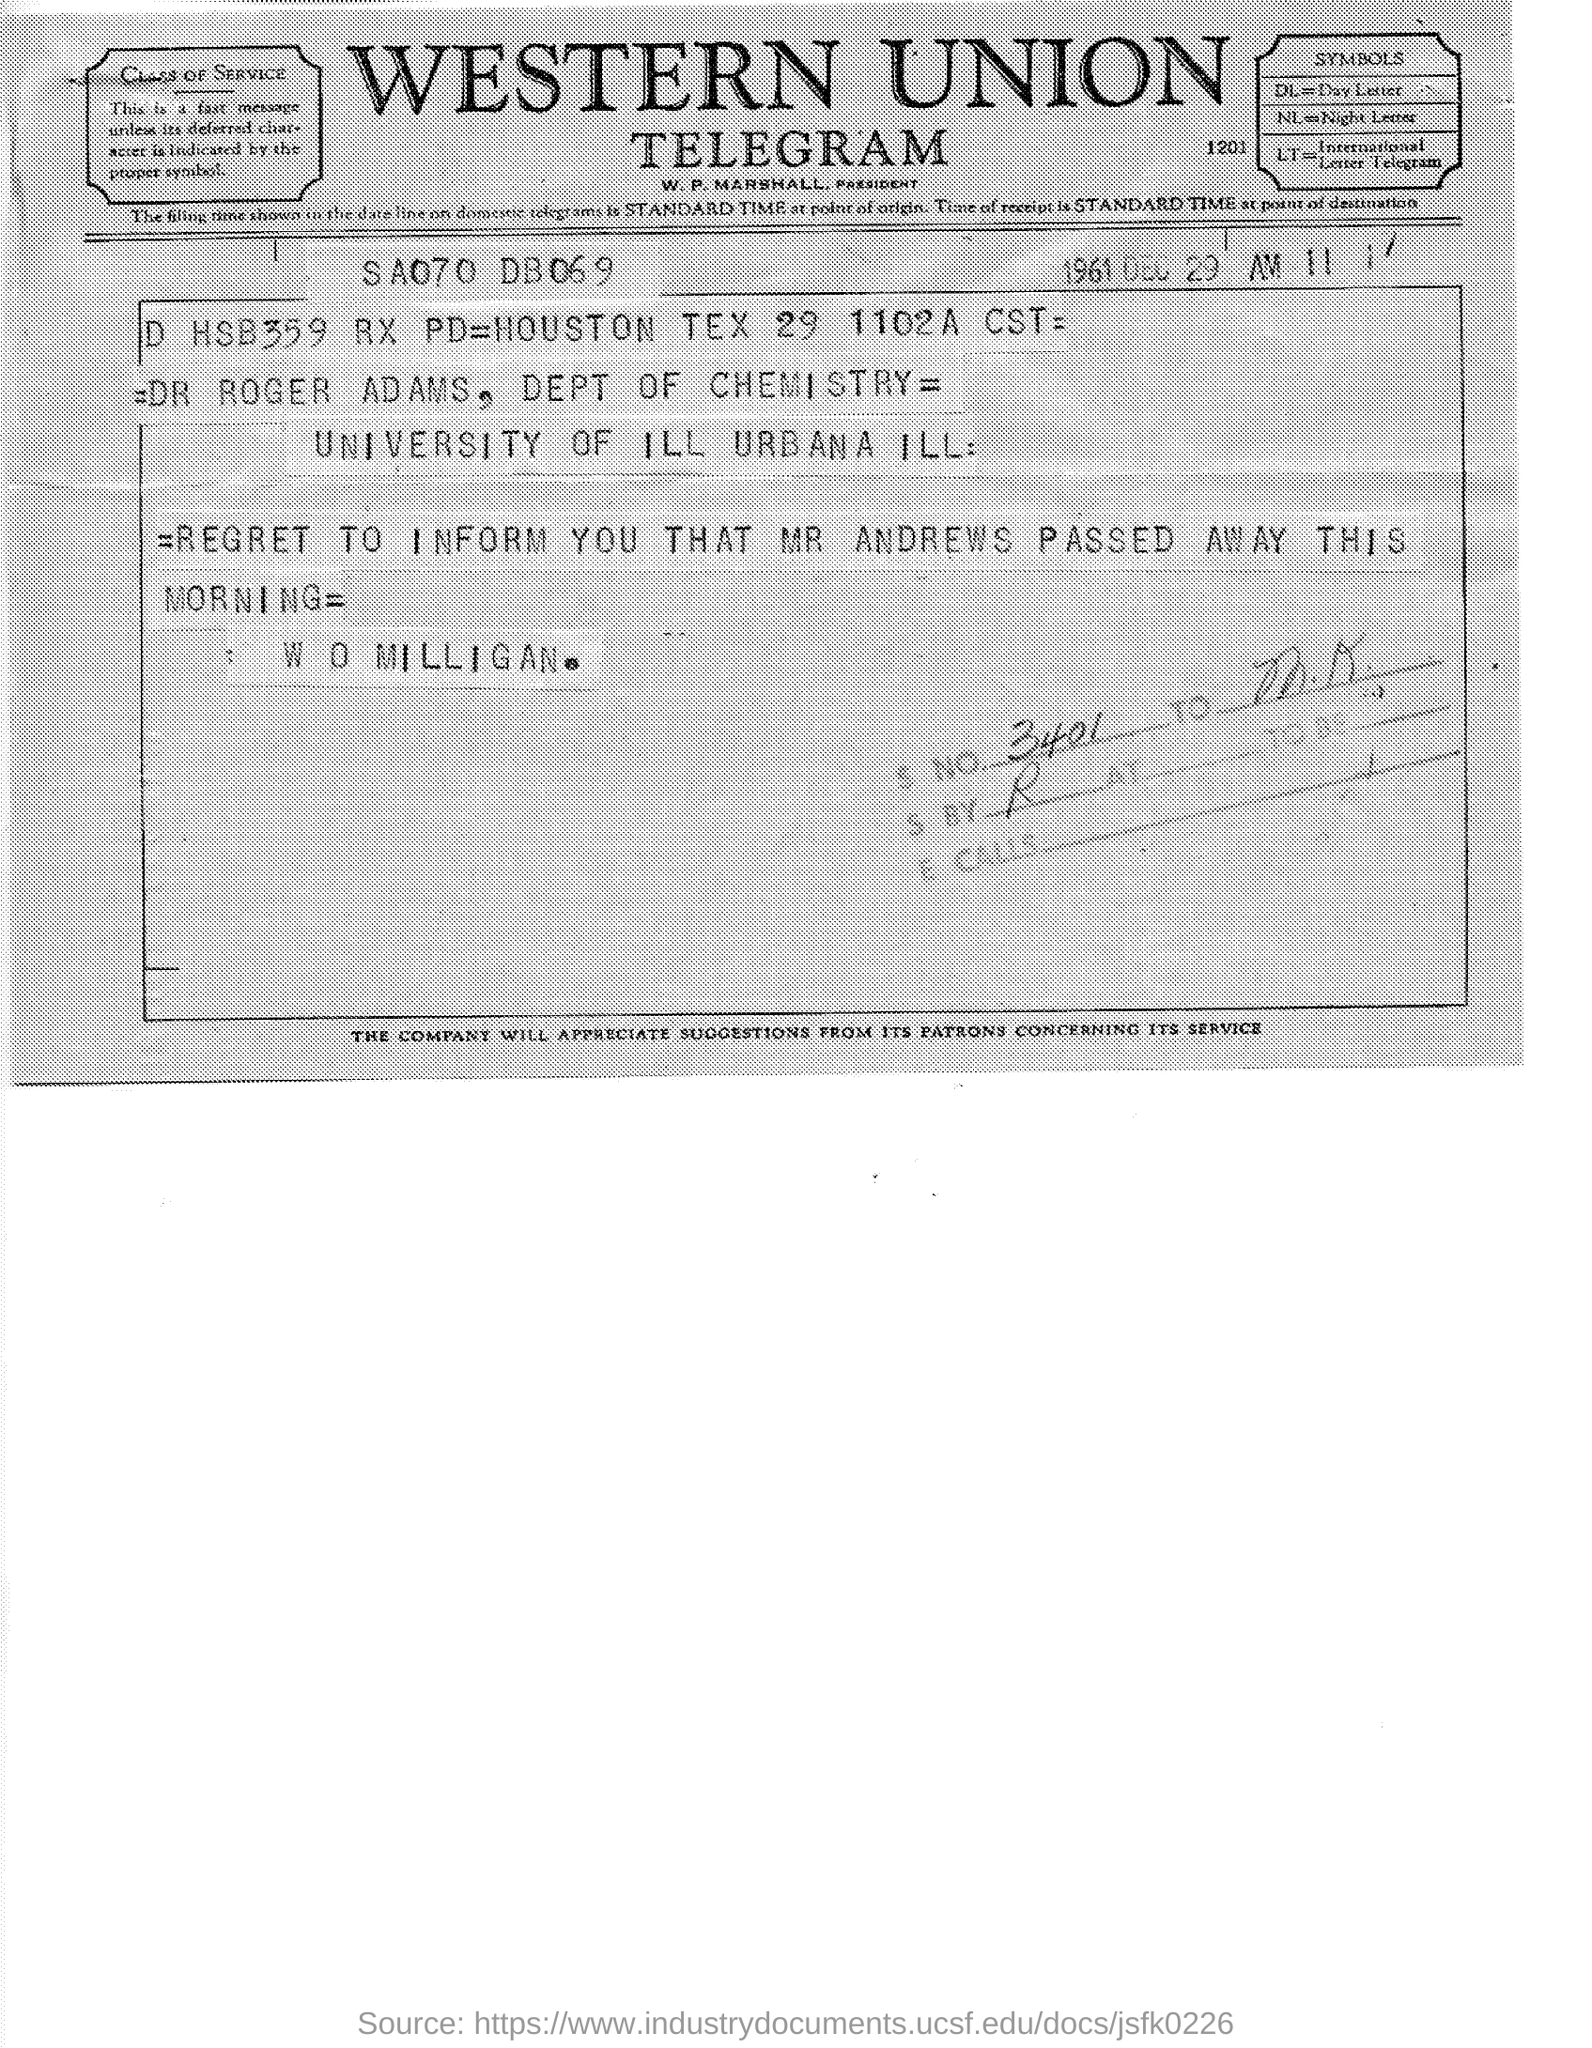What is the date mentioned in the given telegram ?
Offer a very short reply. 1961 DEC 29. What is the name of the union  ?
Ensure brevity in your answer.  Western union. Who is the president of western union ?
Keep it short and to the point. W.P. MARSHALL. What does dl stands for ?
Provide a succinct answer. Day letter. What does nl stands for ?
Provide a short and direct response. Night Letter. Who has passed away this morning as mentioned in the telegram ?
Your answer should be compact. MR ANDREWS. 